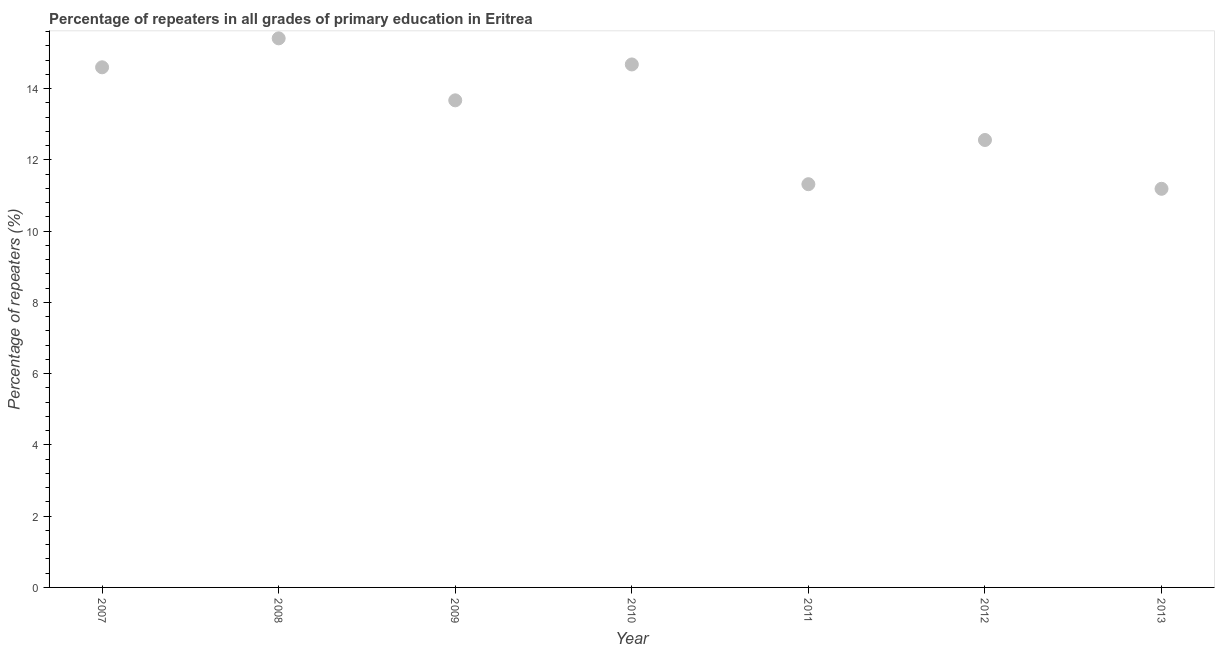What is the percentage of repeaters in primary education in 2013?
Ensure brevity in your answer.  11.19. Across all years, what is the maximum percentage of repeaters in primary education?
Keep it short and to the point. 15.41. Across all years, what is the minimum percentage of repeaters in primary education?
Keep it short and to the point. 11.19. In which year was the percentage of repeaters in primary education maximum?
Offer a terse response. 2008. In which year was the percentage of repeaters in primary education minimum?
Offer a very short reply. 2013. What is the sum of the percentage of repeaters in primary education?
Your response must be concise. 93.42. What is the difference between the percentage of repeaters in primary education in 2007 and 2009?
Provide a succinct answer. 0.93. What is the average percentage of repeaters in primary education per year?
Give a very brief answer. 13.35. What is the median percentage of repeaters in primary education?
Offer a very short reply. 13.67. What is the ratio of the percentage of repeaters in primary education in 2011 to that in 2012?
Offer a very short reply. 0.9. Is the percentage of repeaters in primary education in 2010 less than that in 2012?
Your answer should be compact. No. Is the difference between the percentage of repeaters in primary education in 2012 and 2013 greater than the difference between any two years?
Give a very brief answer. No. What is the difference between the highest and the second highest percentage of repeaters in primary education?
Make the answer very short. 0.73. Is the sum of the percentage of repeaters in primary education in 2009 and 2013 greater than the maximum percentage of repeaters in primary education across all years?
Your answer should be very brief. Yes. What is the difference between the highest and the lowest percentage of repeaters in primary education?
Your response must be concise. 4.22. In how many years, is the percentage of repeaters in primary education greater than the average percentage of repeaters in primary education taken over all years?
Ensure brevity in your answer.  4. How many dotlines are there?
Your answer should be very brief. 1. What is the title of the graph?
Provide a succinct answer. Percentage of repeaters in all grades of primary education in Eritrea. What is the label or title of the X-axis?
Your response must be concise. Year. What is the label or title of the Y-axis?
Provide a short and direct response. Percentage of repeaters (%). What is the Percentage of repeaters (%) in 2007?
Give a very brief answer. 14.6. What is the Percentage of repeaters (%) in 2008?
Your response must be concise. 15.41. What is the Percentage of repeaters (%) in 2009?
Provide a short and direct response. 13.67. What is the Percentage of repeaters (%) in 2010?
Provide a succinct answer. 14.68. What is the Percentage of repeaters (%) in 2011?
Make the answer very short. 11.32. What is the Percentage of repeaters (%) in 2012?
Ensure brevity in your answer.  12.56. What is the Percentage of repeaters (%) in 2013?
Your answer should be very brief. 11.19. What is the difference between the Percentage of repeaters (%) in 2007 and 2008?
Provide a succinct answer. -0.81. What is the difference between the Percentage of repeaters (%) in 2007 and 2009?
Give a very brief answer. 0.93. What is the difference between the Percentage of repeaters (%) in 2007 and 2010?
Keep it short and to the point. -0.08. What is the difference between the Percentage of repeaters (%) in 2007 and 2011?
Provide a short and direct response. 3.28. What is the difference between the Percentage of repeaters (%) in 2007 and 2012?
Provide a short and direct response. 2.04. What is the difference between the Percentage of repeaters (%) in 2007 and 2013?
Offer a very short reply. 3.41. What is the difference between the Percentage of repeaters (%) in 2008 and 2009?
Your answer should be compact. 1.74. What is the difference between the Percentage of repeaters (%) in 2008 and 2010?
Ensure brevity in your answer.  0.73. What is the difference between the Percentage of repeaters (%) in 2008 and 2011?
Provide a succinct answer. 4.09. What is the difference between the Percentage of repeaters (%) in 2008 and 2012?
Your response must be concise. 2.85. What is the difference between the Percentage of repeaters (%) in 2008 and 2013?
Ensure brevity in your answer.  4.22. What is the difference between the Percentage of repeaters (%) in 2009 and 2010?
Keep it short and to the point. -1.01. What is the difference between the Percentage of repeaters (%) in 2009 and 2011?
Keep it short and to the point. 2.35. What is the difference between the Percentage of repeaters (%) in 2009 and 2012?
Your answer should be very brief. 1.11. What is the difference between the Percentage of repeaters (%) in 2009 and 2013?
Keep it short and to the point. 2.48. What is the difference between the Percentage of repeaters (%) in 2010 and 2011?
Keep it short and to the point. 3.36. What is the difference between the Percentage of repeaters (%) in 2010 and 2012?
Offer a very short reply. 2.12. What is the difference between the Percentage of repeaters (%) in 2010 and 2013?
Your response must be concise. 3.49. What is the difference between the Percentage of repeaters (%) in 2011 and 2012?
Offer a terse response. -1.24. What is the difference between the Percentage of repeaters (%) in 2011 and 2013?
Your answer should be very brief. 0.13. What is the difference between the Percentage of repeaters (%) in 2012 and 2013?
Provide a succinct answer. 1.37. What is the ratio of the Percentage of repeaters (%) in 2007 to that in 2008?
Keep it short and to the point. 0.95. What is the ratio of the Percentage of repeaters (%) in 2007 to that in 2009?
Provide a short and direct response. 1.07. What is the ratio of the Percentage of repeaters (%) in 2007 to that in 2010?
Offer a terse response. 0.99. What is the ratio of the Percentage of repeaters (%) in 2007 to that in 2011?
Provide a short and direct response. 1.29. What is the ratio of the Percentage of repeaters (%) in 2007 to that in 2012?
Ensure brevity in your answer.  1.16. What is the ratio of the Percentage of repeaters (%) in 2007 to that in 2013?
Your answer should be compact. 1.3. What is the ratio of the Percentage of repeaters (%) in 2008 to that in 2009?
Make the answer very short. 1.13. What is the ratio of the Percentage of repeaters (%) in 2008 to that in 2010?
Your answer should be compact. 1.05. What is the ratio of the Percentage of repeaters (%) in 2008 to that in 2011?
Your answer should be very brief. 1.36. What is the ratio of the Percentage of repeaters (%) in 2008 to that in 2012?
Offer a very short reply. 1.23. What is the ratio of the Percentage of repeaters (%) in 2008 to that in 2013?
Your response must be concise. 1.38. What is the ratio of the Percentage of repeaters (%) in 2009 to that in 2010?
Keep it short and to the point. 0.93. What is the ratio of the Percentage of repeaters (%) in 2009 to that in 2011?
Your response must be concise. 1.21. What is the ratio of the Percentage of repeaters (%) in 2009 to that in 2012?
Provide a short and direct response. 1.09. What is the ratio of the Percentage of repeaters (%) in 2009 to that in 2013?
Your answer should be compact. 1.22. What is the ratio of the Percentage of repeaters (%) in 2010 to that in 2011?
Keep it short and to the point. 1.3. What is the ratio of the Percentage of repeaters (%) in 2010 to that in 2012?
Ensure brevity in your answer.  1.17. What is the ratio of the Percentage of repeaters (%) in 2010 to that in 2013?
Provide a short and direct response. 1.31. What is the ratio of the Percentage of repeaters (%) in 2011 to that in 2012?
Keep it short and to the point. 0.9. What is the ratio of the Percentage of repeaters (%) in 2012 to that in 2013?
Your answer should be compact. 1.12. 